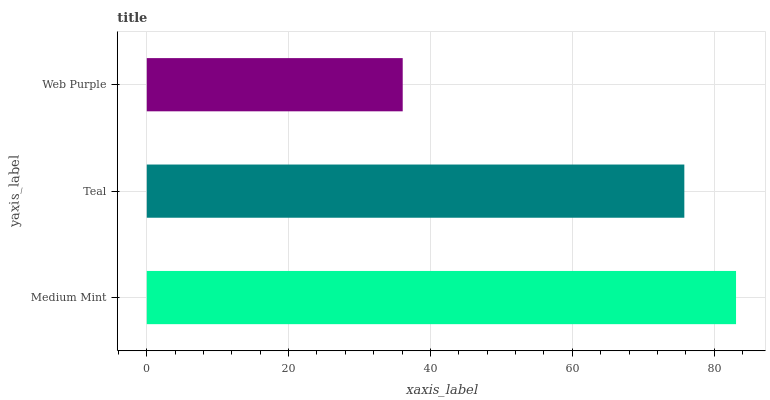Is Web Purple the minimum?
Answer yes or no. Yes. Is Medium Mint the maximum?
Answer yes or no. Yes. Is Teal the minimum?
Answer yes or no. No. Is Teal the maximum?
Answer yes or no. No. Is Medium Mint greater than Teal?
Answer yes or no. Yes. Is Teal less than Medium Mint?
Answer yes or no. Yes. Is Teal greater than Medium Mint?
Answer yes or no. No. Is Medium Mint less than Teal?
Answer yes or no. No. Is Teal the high median?
Answer yes or no. Yes. Is Teal the low median?
Answer yes or no. Yes. Is Web Purple the high median?
Answer yes or no. No. Is Web Purple the low median?
Answer yes or no. No. 